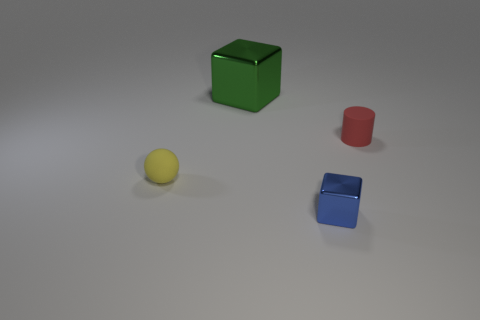Add 1 cyan matte objects. How many objects exist? 5 Subtract all spheres. How many objects are left? 3 Subtract all green blocks. How many blocks are left? 1 Subtract all small blue blocks. Subtract all small cylinders. How many objects are left? 2 Add 1 spheres. How many spheres are left? 2 Add 1 shiny objects. How many shiny objects exist? 3 Subtract 1 red cylinders. How many objects are left? 3 Subtract 2 cubes. How many cubes are left? 0 Subtract all gray blocks. Subtract all gray spheres. How many blocks are left? 2 Subtract all blue spheres. How many green blocks are left? 1 